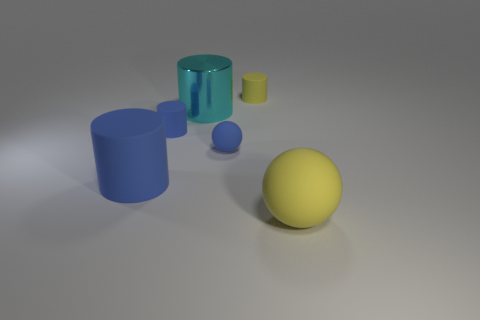Add 1 cyan cylinders. How many objects exist? 7 Subtract all cylinders. How many objects are left? 2 Subtract 0 purple cubes. How many objects are left? 6 Subtract all large blue matte cylinders. Subtract all large yellow matte balls. How many objects are left? 4 Add 3 blue spheres. How many blue spheres are left? 4 Add 5 tiny purple matte cylinders. How many tiny purple matte cylinders exist? 5 